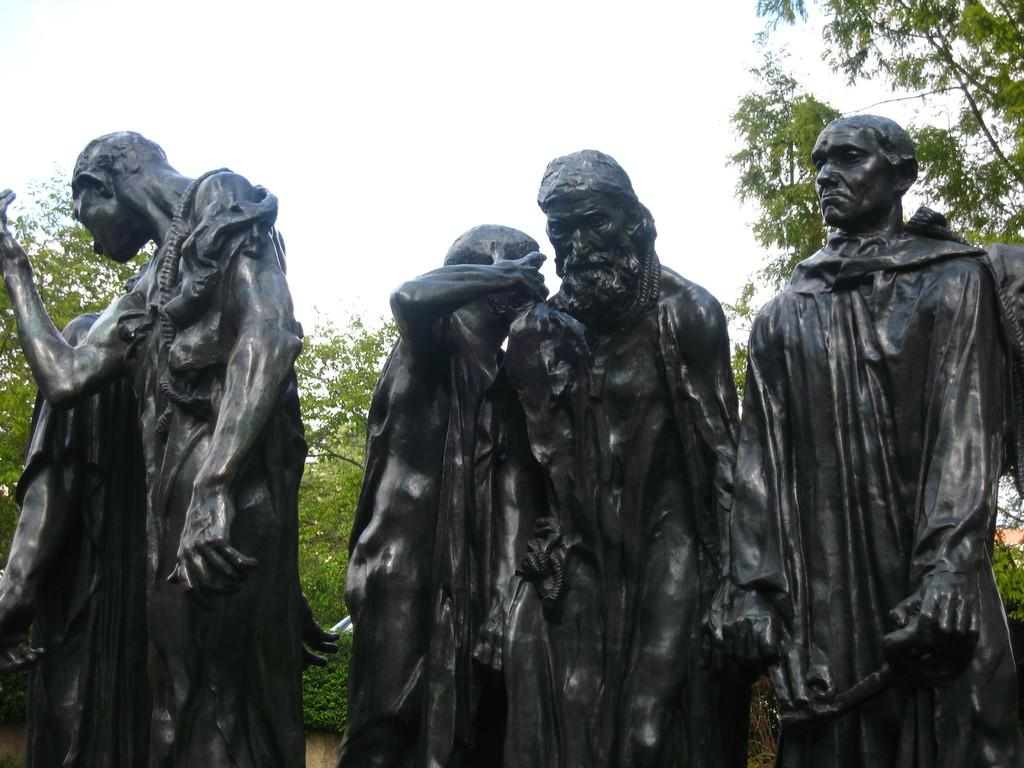What type of objects are depicted in the image? There are statues of people in the image. What can be seen in the background of the image? There are trees and the sky visible in the background of the image. What color is the cord hanging from the orange tree in the image? There is no cord or orange tree present in the image; it only features statues of people and a background with trees and the sky. 